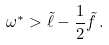Convert formula to latex. <formula><loc_0><loc_0><loc_500><loc_500>\omega ^ { * } > \tilde { \ell } - \frac { 1 } { 2 } \tilde { f } \, .</formula> 